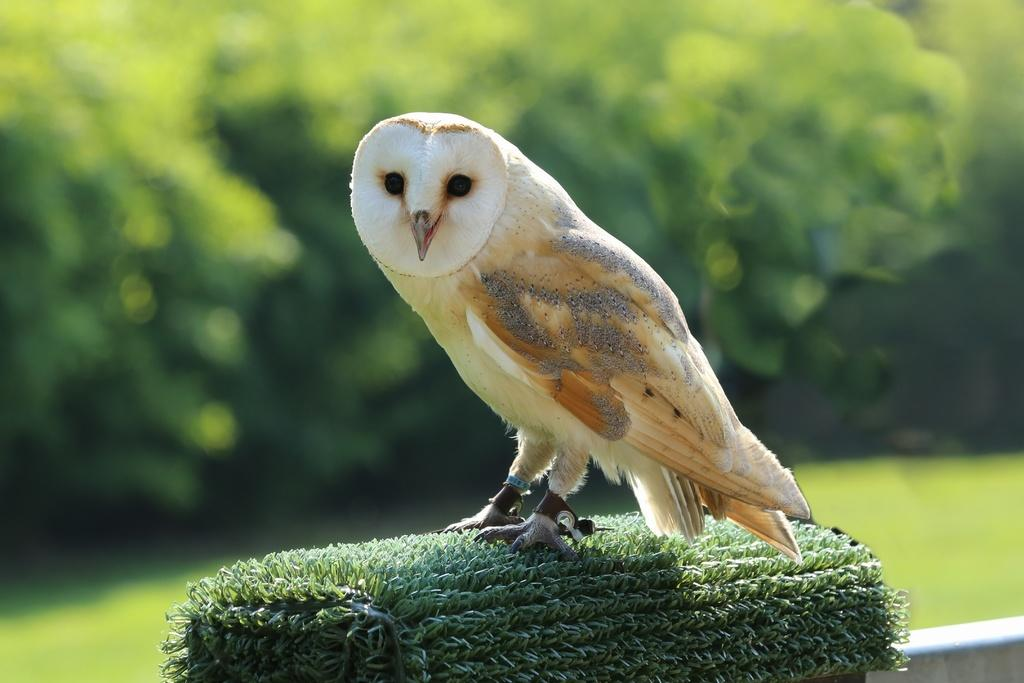What type of animal is in the image? There is a bird in the image. What can be seen in the background of the image? There are green trees in the background of the image. Is the bird driving a car in the image? No, there is no car or driving activity depicted in the image. 